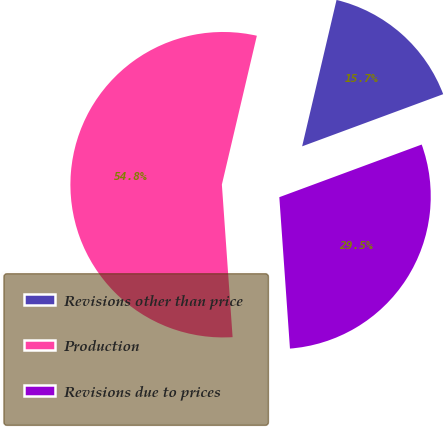Convert chart to OTSL. <chart><loc_0><loc_0><loc_500><loc_500><pie_chart><fcel>Revisions other than price<fcel>Production<fcel>Revisions due to prices<nl><fcel>15.69%<fcel>54.79%<fcel>29.52%<nl></chart> 